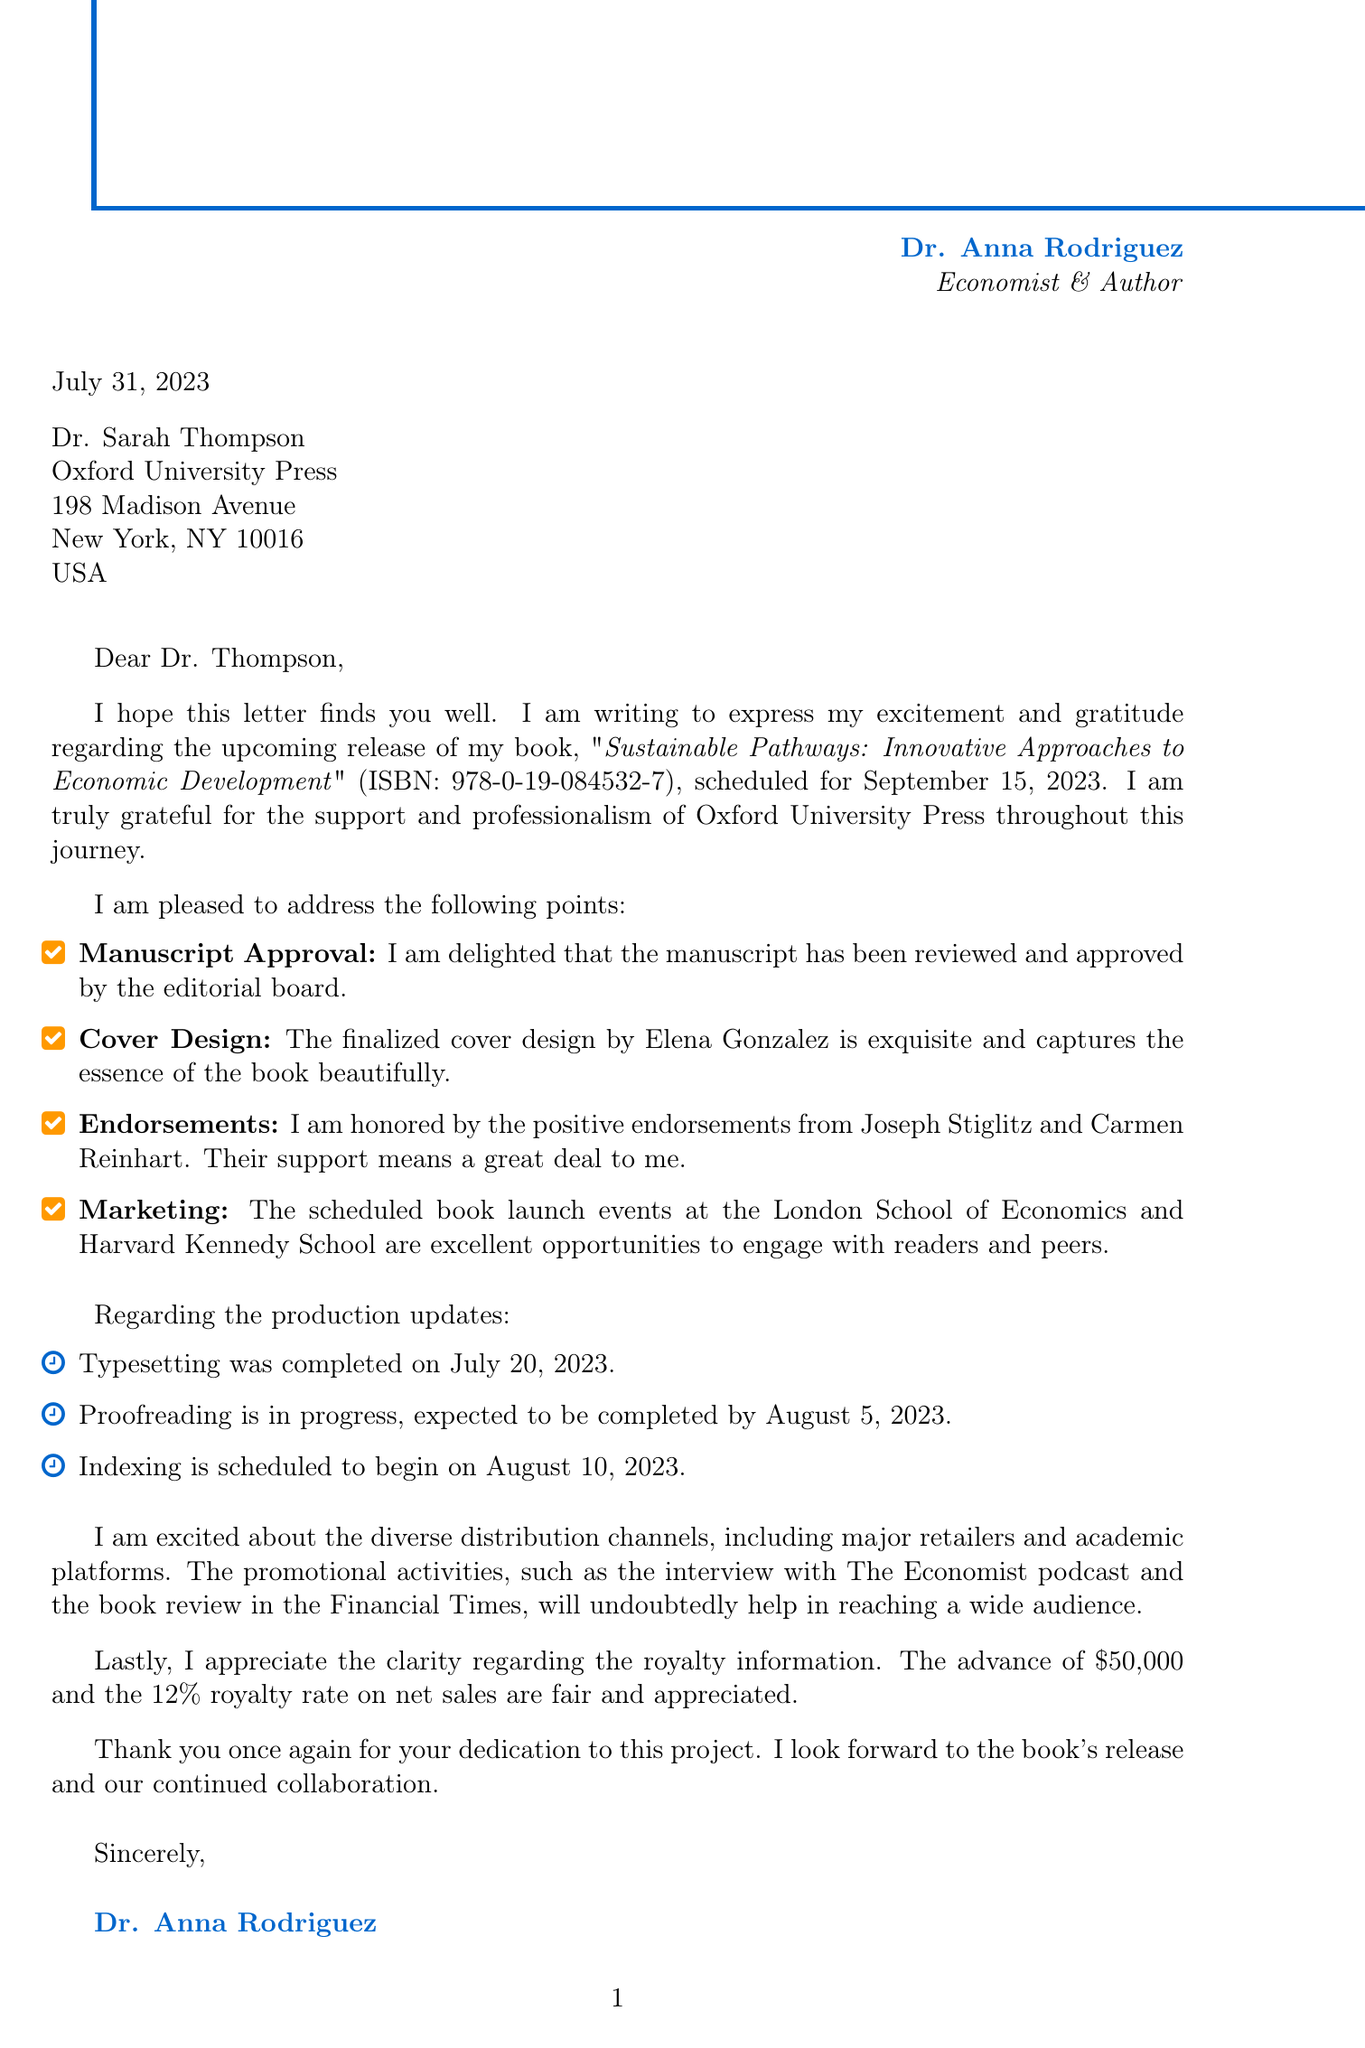What is the name of the publisher? The name of the publisher is explicitly mentioned at the beginning of the document as Oxford University Press.
Answer: Oxford University Press Who is the editor of the book? The editor's name is listed in the address section of the document as Dr. Sarah Thompson.
Answer: Dr. Sarah Thompson What is the ISBN of the book? The ISBN number is provided in the book details section, specifically mentioned before the release date.
Answer: 978-0-19-084532-7 When is the book scheduled for release? The document states the release date as September 15, 2023, within the book details section.
Answer: September 15, 2023 What is the total page count of the book? The total page count is provided in the book details, an important characteristic of the book's format.
Answer: 384 Who designed the cover of the book? The cover design credit is given to Elena Gonzalez, mentioned under the correspondence points.
Answer: Elena Gonzalez What is the royalty rate mentioned in the document? The document explicitly states the royalty rate as a percentage of net sales for the book.
Answer: 12% of net sales Which academic platforms are mentioned for distribution? The document lists specific academic channels for distributing the book, indicating its reach in academia.
Answer: JSTOR, ProQuest, university bookstores What promotional activity is scheduled for September 20, 2023? The document specifies an author interview with The Economist podcast scheduled on this date.
Answer: Author interview What is the advance payment amount mentioned in the royalty information? The advance payment is clearly stated in the royalty information section of the document.
Answer: $50,000 